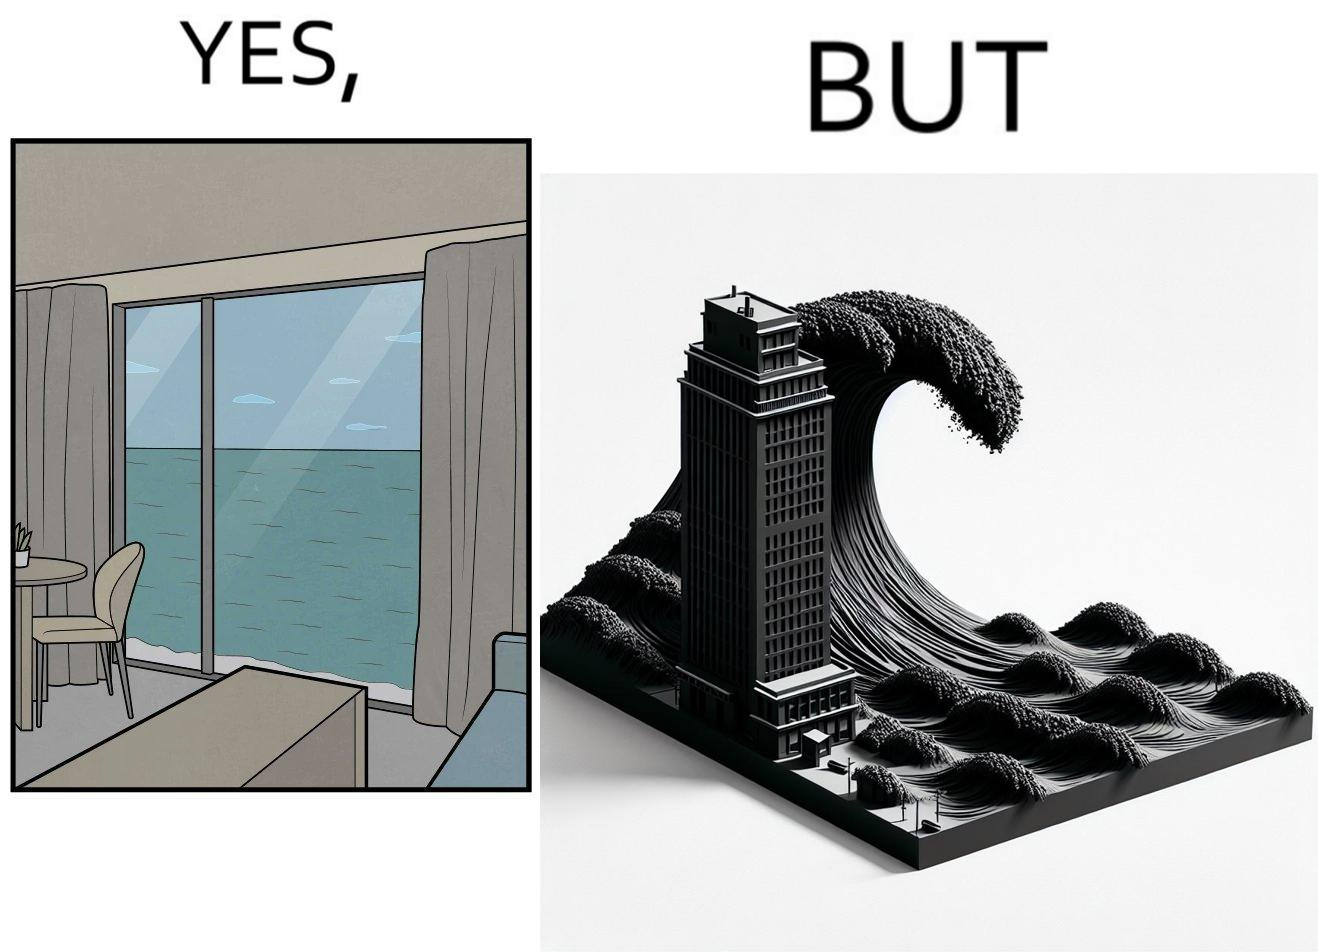Why is this image considered satirical? The same sea which gives us a relaxation on a normal day can pose a danger to us sometimes like during a tsunami 